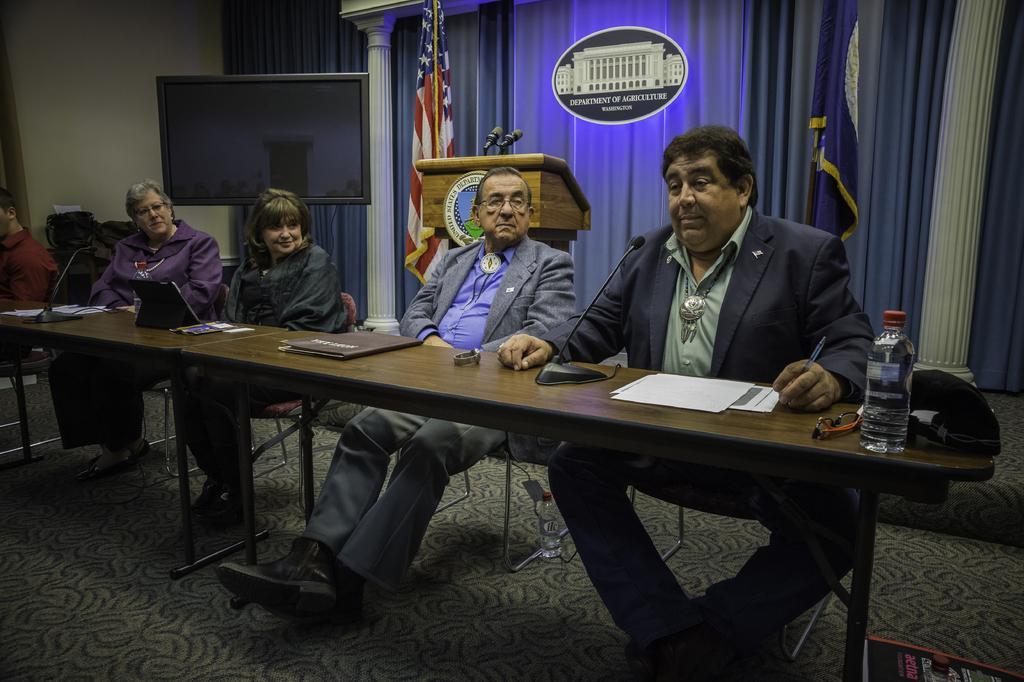Please provide a concise description of this image. In this picture there are a group of people sitting on the chair and have a wooden table behind them with microphones. There is also a table in front of them with some files watches and spectacles, hot, water bottle and one of the person is staring at the people who is in the front and this woman is smiling. In the background there is a flag, a television and a curtain. 